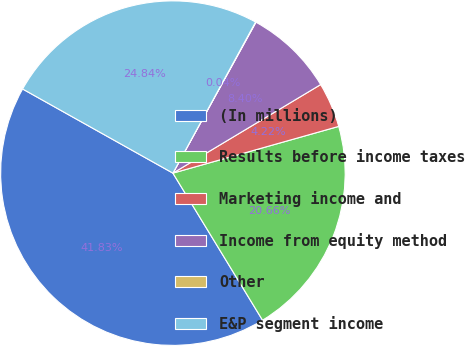Convert chart. <chart><loc_0><loc_0><loc_500><loc_500><pie_chart><fcel>(In millions)<fcel>Results before income taxes<fcel>Marketing income and<fcel>Income from equity method<fcel>Other<fcel>E&P segment income<nl><fcel>41.83%<fcel>20.66%<fcel>4.22%<fcel>8.4%<fcel>0.04%<fcel>24.84%<nl></chart> 